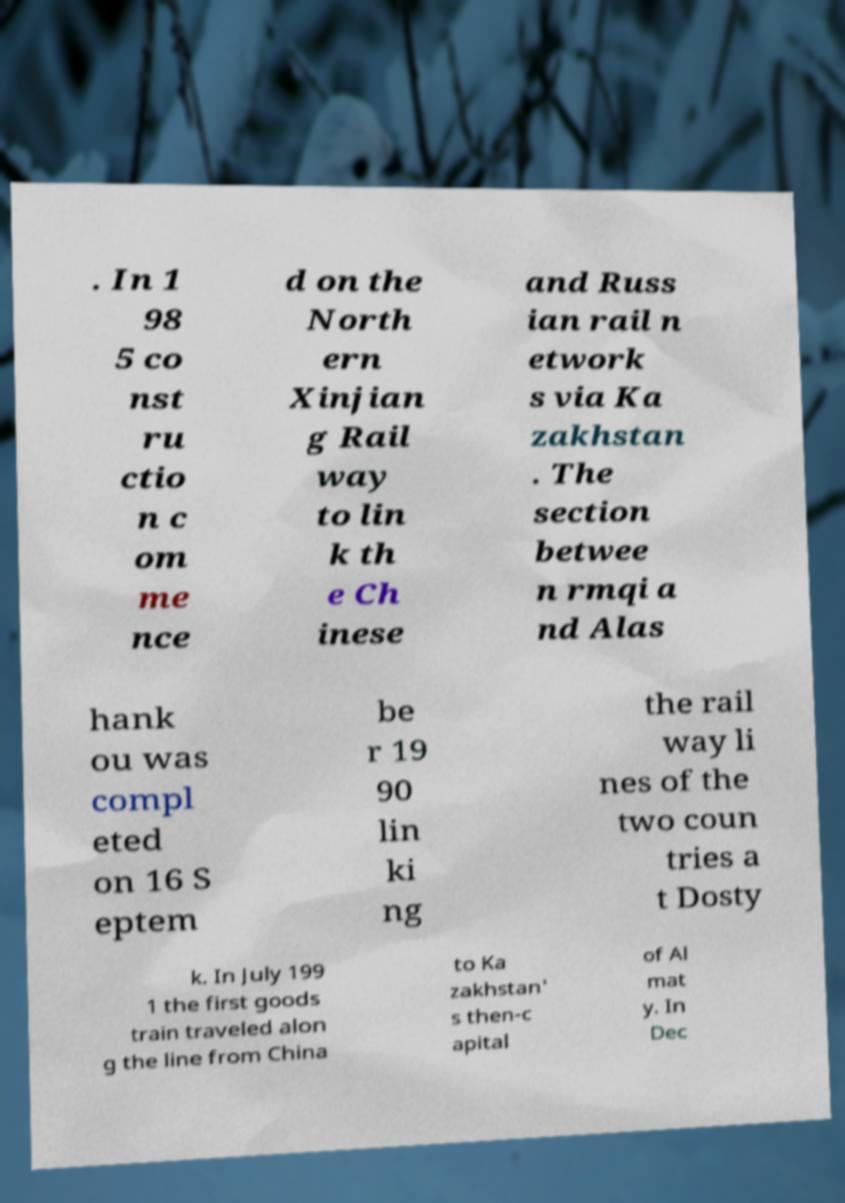Could you extract and type out the text from this image? . In 1 98 5 co nst ru ctio n c om me nce d on the North ern Xinjian g Rail way to lin k th e Ch inese and Russ ian rail n etwork s via Ka zakhstan . The section betwee n rmqi a nd Alas hank ou was compl eted on 16 S eptem be r 19 90 lin ki ng the rail way li nes of the two coun tries a t Dosty k. In July 199 1 the first goods train traveled alon g the line from China to Ka zakhstan' s then-c apital of Al mat y. In Dec 